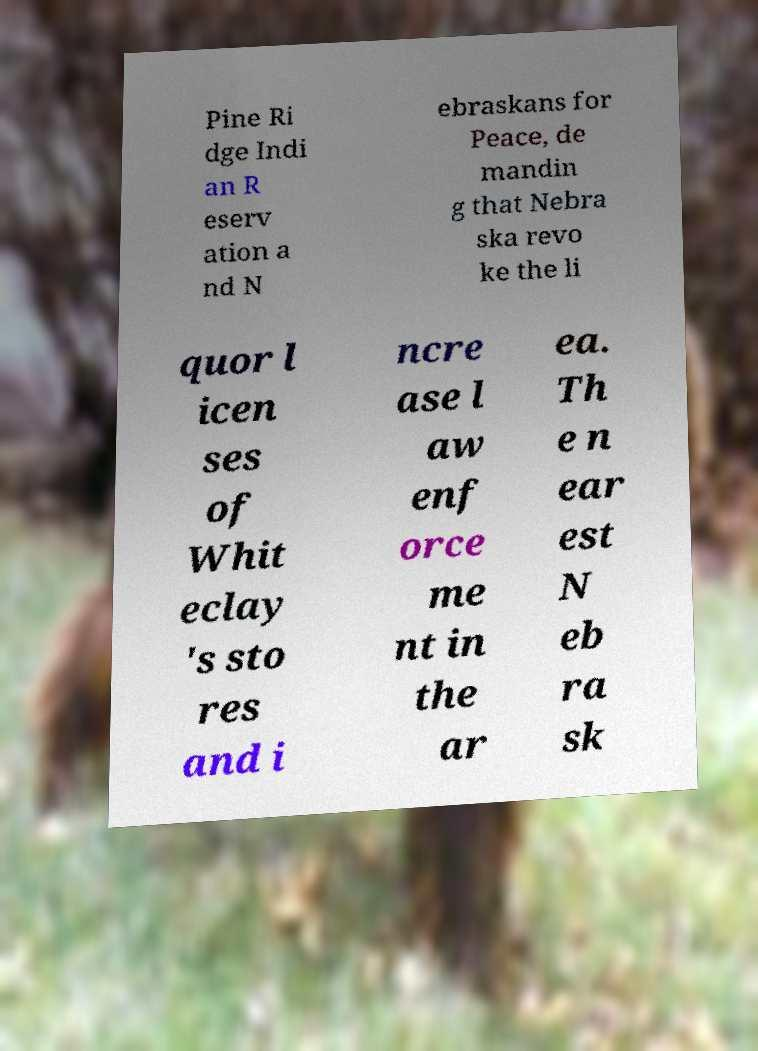There's text embedded in this image that I need extracted. Can you transcribe it verbatim? Pine Ri dge Indi an R eserv ation a nd N ebraskans for Peace, de mandin g that Nebra ska revo ke the li quor l icen ses of Whit eclay 's sto res and i ncre ase l aw enf orce me nt in the ar ea. Th e n ear est N eb ra sk 